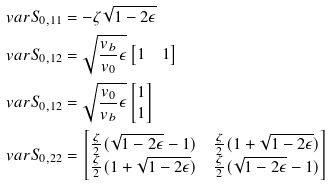Convert formula to latex. <formula><loc_0><loc_0><loc_500><loc_500>\ v a r S _ { 0 , 1 1 } & = - \zeta \sqrt { 1 - 2 \epsilon } \\ \ v a r S _ { 0 , 1 2 } & = \sqrt { \frac { v _ { b } } { v _ { 0 } } \epsilon } \begin{bmatrix} 1 & 1 \end{bmatrix} \\ \ v a r S _ { 0 , 1 2 } & = \sqrt { \frac { v _ { 0 } } { v _ { b } } \epsilon } \begin{bmatrix} 1 \\ 1 \end{bmatrix} \\ \ v a r S _ { 0 , 2 2 } & = \begin{bmatrix} \frac { \zeta } { 2 } ( \sqrt { 1 - 2 \epsilon } - 1 ) & \frac { \zeta } { 2 } ( 1 + \sqrt { 1 - 2 \epsilon } ) \\ \frac { \zeta } { 2 } ( 1 + \sqrt { 1 - 2 \epsilon } ) & \frac { \zeta } { 2 } ( \sqrt { 1 - 2 \epsilon } - 1 ) \end{bmatrix}</formula> 